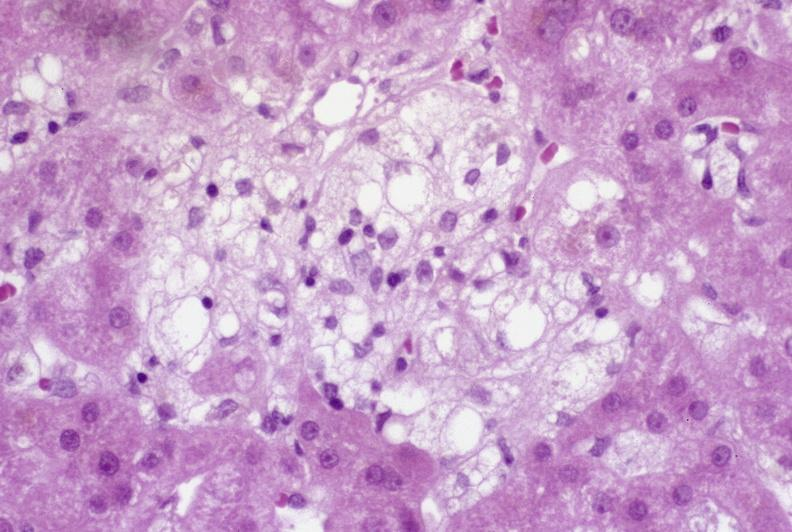what does this image show?
Answer the question using a single word or phrase. Recovery of ducts 